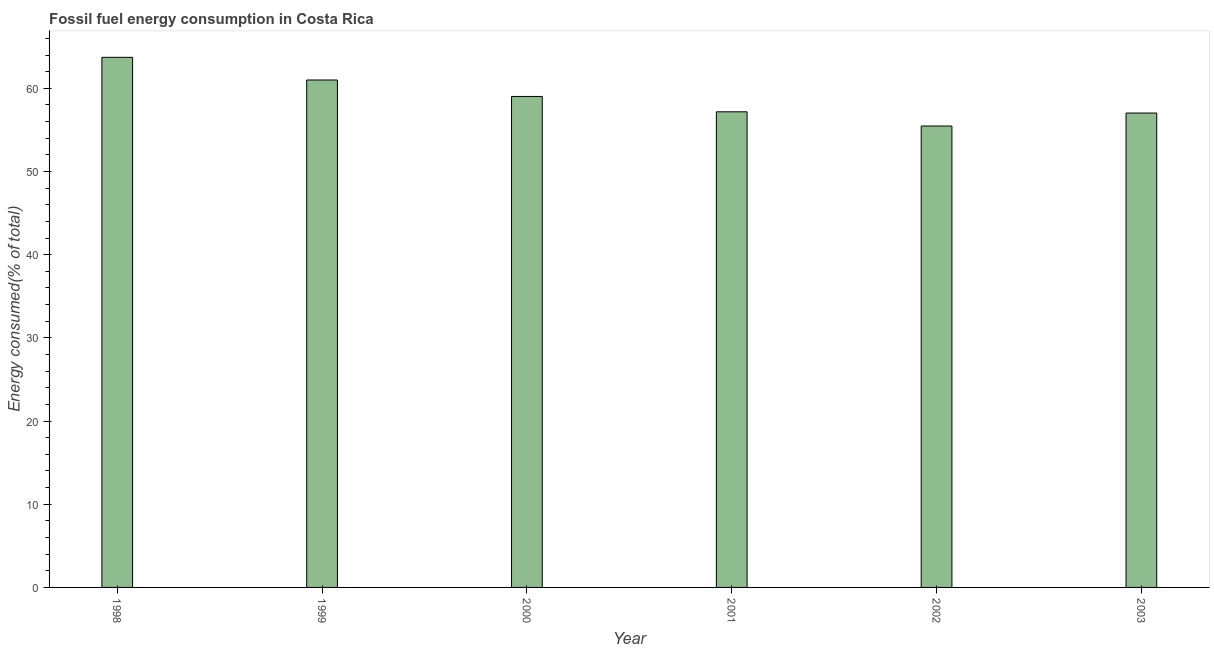What is the title of the graph?
Your response must be concise. Fossil fuel energy consumption in Costa Rica. What is the label or title of the Y-axis?
Provide a succinct answer. Energy consumed(% of total). What is the fossil fuel energy consumption in 2003?
Provide a succinct answer. 57.03. Across all years, what is the maximum fossil fuel energy consumption?
Offer a very short reply. 63.73. Across all years, what is the minimum fossil fuel energy consumption?
Your response must be concise. 55.47. In which year was the fossil fuel energy consumption minimum?
Your response must be concise. 2002. What is the sum of the fossil fuel energy consumption?
Provide a succinct answer. 353.44. What is the difference between the fossil fuel energy consumption in 1998 and 1999?
Ensure brevity in your answer.  2.73. What is the average fossil fuel energy consumption per year?
Your answer should be compact. 58.91. What is the median fossil fuel energy consumption?
Your answer should be compact. 58.1. What is the ratio of the fossil fuel energy consumption in 1998 to that in 2000?
Give a very brief answer. 1.08. What is the difference between the highest and the second highest fossil fuel energy consumption?
Provide a short and direct response. 2.73. Is the sum of the fossil fuel energy consumption in 1999 and 2001 greater than the maximum fossil fuel energy consumption across all years?
Your answer should be compact. Yes. What is the difference between the highest and the lowest fossil fuel energy consumption?
Your response must be concise. 8.26. In how many years, is the fossil fuel energy consumption greater than the average fossil fuel energy consumption taken over all years?
Provide a short and direct response. 3. How many bars are there?
Provide a short and direct response. 6. What is the difference between two consecutive major ticks on the Y-axis?
Your response must be concise. 10. Are the values on the major ticks of Y-axis written in scientific E-notation?
Make the answer very short. No. What is the Energy consumed(% of total) in 1998?
Make the answer very short. 63.73. What is the Energy consumed(% of total) in 1999?
Make the answer very short. 61. What is the Energy consumed(% of total) of 2000?
Make the answer very short. 59.03. What is the Energy consumed(% of total) in 2001?
Give a very brief answer. 57.18. What is the Energy consumed(% of total) of 2002?
Offer a very short reply. 55.47. What is the Energy consumed(% of total) of 2003?
Provide a short and direct response. 57.03. What is the difference between the Energy consumed(% of total) in 1998 and 1999?
Offer a very short reply. 2.73. What is the difference between the Energy consumed(% of total) in 1998 and 2000?
Keep it short and to the point. 4.7. What is the difference between the Energy consumed(% of total) in 1998 and 2001?
Offer a very short reply. 6.55. What is the difference between the Energy consumed(% of total) in 1998 and 2002?
Offer a terse response. 8.26. What is the difference between the Energy consumed(% of total) in 1998 and 2003?
Provide a short and direct response. 6.7. What is the difference between the Energy consumed(% of total) in 1999 and 2000?
Ensure brevity in your answer.  1.98. What is the difference between the Energy consumed(% of total) in 1999 and 2001?
Give a very brief answer. 3.82. What is the difference between the Energy consumed(% of total) in 1999 and 2002?
Your answer should be compact. 5.53. What is the difference between the Energy consumed(% of total) in 1999 and 2003?
Provide a short and direct response. 3.97. What is the difference between the Energy consumed(% of total) in 2000 and 2001?
Your answer should be compact. 1.85. What is the difference between the Energy consumed(% of total) in 2000 and 2002?
Offer a very short reply. 3.56. What is the difference between the Energy consumed(% of total) in 2000 and 2003?
Offer a terse response. 2. What is the difference between the Energy consumed(% of total) in 2001 and 2002?
Offer a terse response. 1.71. What is the difference between the Energy consumed(% of total) in 2001 and 2003?
Your answer should be very brief. 0.15. What is the difference between the Energy consumed(% of total) in 2002 and 2003?
Ensure brevity in your answer.  -1.56. What is the ratio of the Energy consumed(% of total) in 1998 to that in 1999?
Offer a terse response. 1.04. What is the ratio of the Energy consumed(% of total) in 1998 to that in 2000?
Your answer should be compact. 1.08. What is the ratio of the Energy consumed(% of total) in 1998 to that in 2001?
Keep it short and to the point. 1.11. What is the ratio of the Energy consumed(% of total) in 1998 to that in 2002?
Provide a succinct answer. 1.15. What is the ratio of the Energy consumed(% of total) in 1998 to that in 2003?
Offer a very short reply. 1.12. What is the ratio of the Energy consumed(% of total) in 1999 to that in 2000?
Provide a short and direct response. 1.03. What is the ratio of the Energy consumed(% of total) in 1999 to that in 2001?
Provide a short and direct response. 1.07. What is the ratio of the Energy consumed(% of total) in 1999 to that in 2003?
Give a very brief answer. 1.07. What is the ratio of the Energy consumed(% of total) in 2000 to that in 2001?
Keep it short and to the point. 1.03. What is the ratio of the Energy consumed(% of total) in 2000 to that in 2002?
Your answer should be compact. 1.06. What is the ratio of the Energy consumed(% of total) in 2000 to that in 2003?
Give a very brief answer. 1.03. What is the ratio of the Energy consumed(% of total) in 2001 to that in 2002?
Ensure brevity in your answer.  1.03. What is the ratio of the Energy consumed(% of total) in 2002 to that in 2003?
Your answer should be very brief. 0.97. 